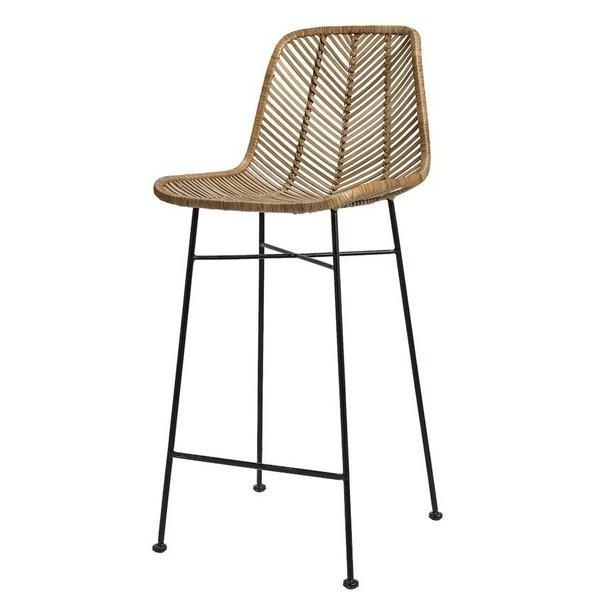How might this bar stool be used in a home kitchen setup? In a home kitchen, this bar stool could serve as an elegant and functional seating option at a kitchen island or breakfast bar. Its sleek design and natural aesthetic would beautifully complement both modern and rustic kitchen decor, seamlessly blending with wooden countertops or sleek marble surfaces. Family members might use the stool to keep the cook company, engage in casual conversations, or enjoy quick meals. Its lightweight nature allows for easy repositioning, making it convenient for different kitchen activities, from meal prep to hosting casual gatherings. The stool’s combination of breathability, durability, and style ensures it remains a beloved fixture in the kitchen. 